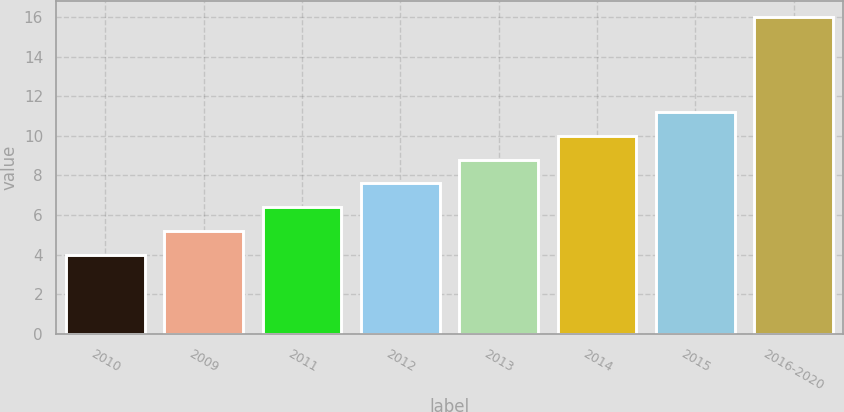<chart> <loc_0><loc_0><loc_500><loc_500><bar_chart><fcel>2010<fcel>2009<fcel>2011<fcel>2012<fcel>2013<fcel>2014<fcel>2015<fcel>2016-2020<nl><fcel>4<fcel>5.2<fcel>6.4<fcel>7.6<fcel>8.8<fcel>10<fcel>11.2<fcel>16<nl></chart> 